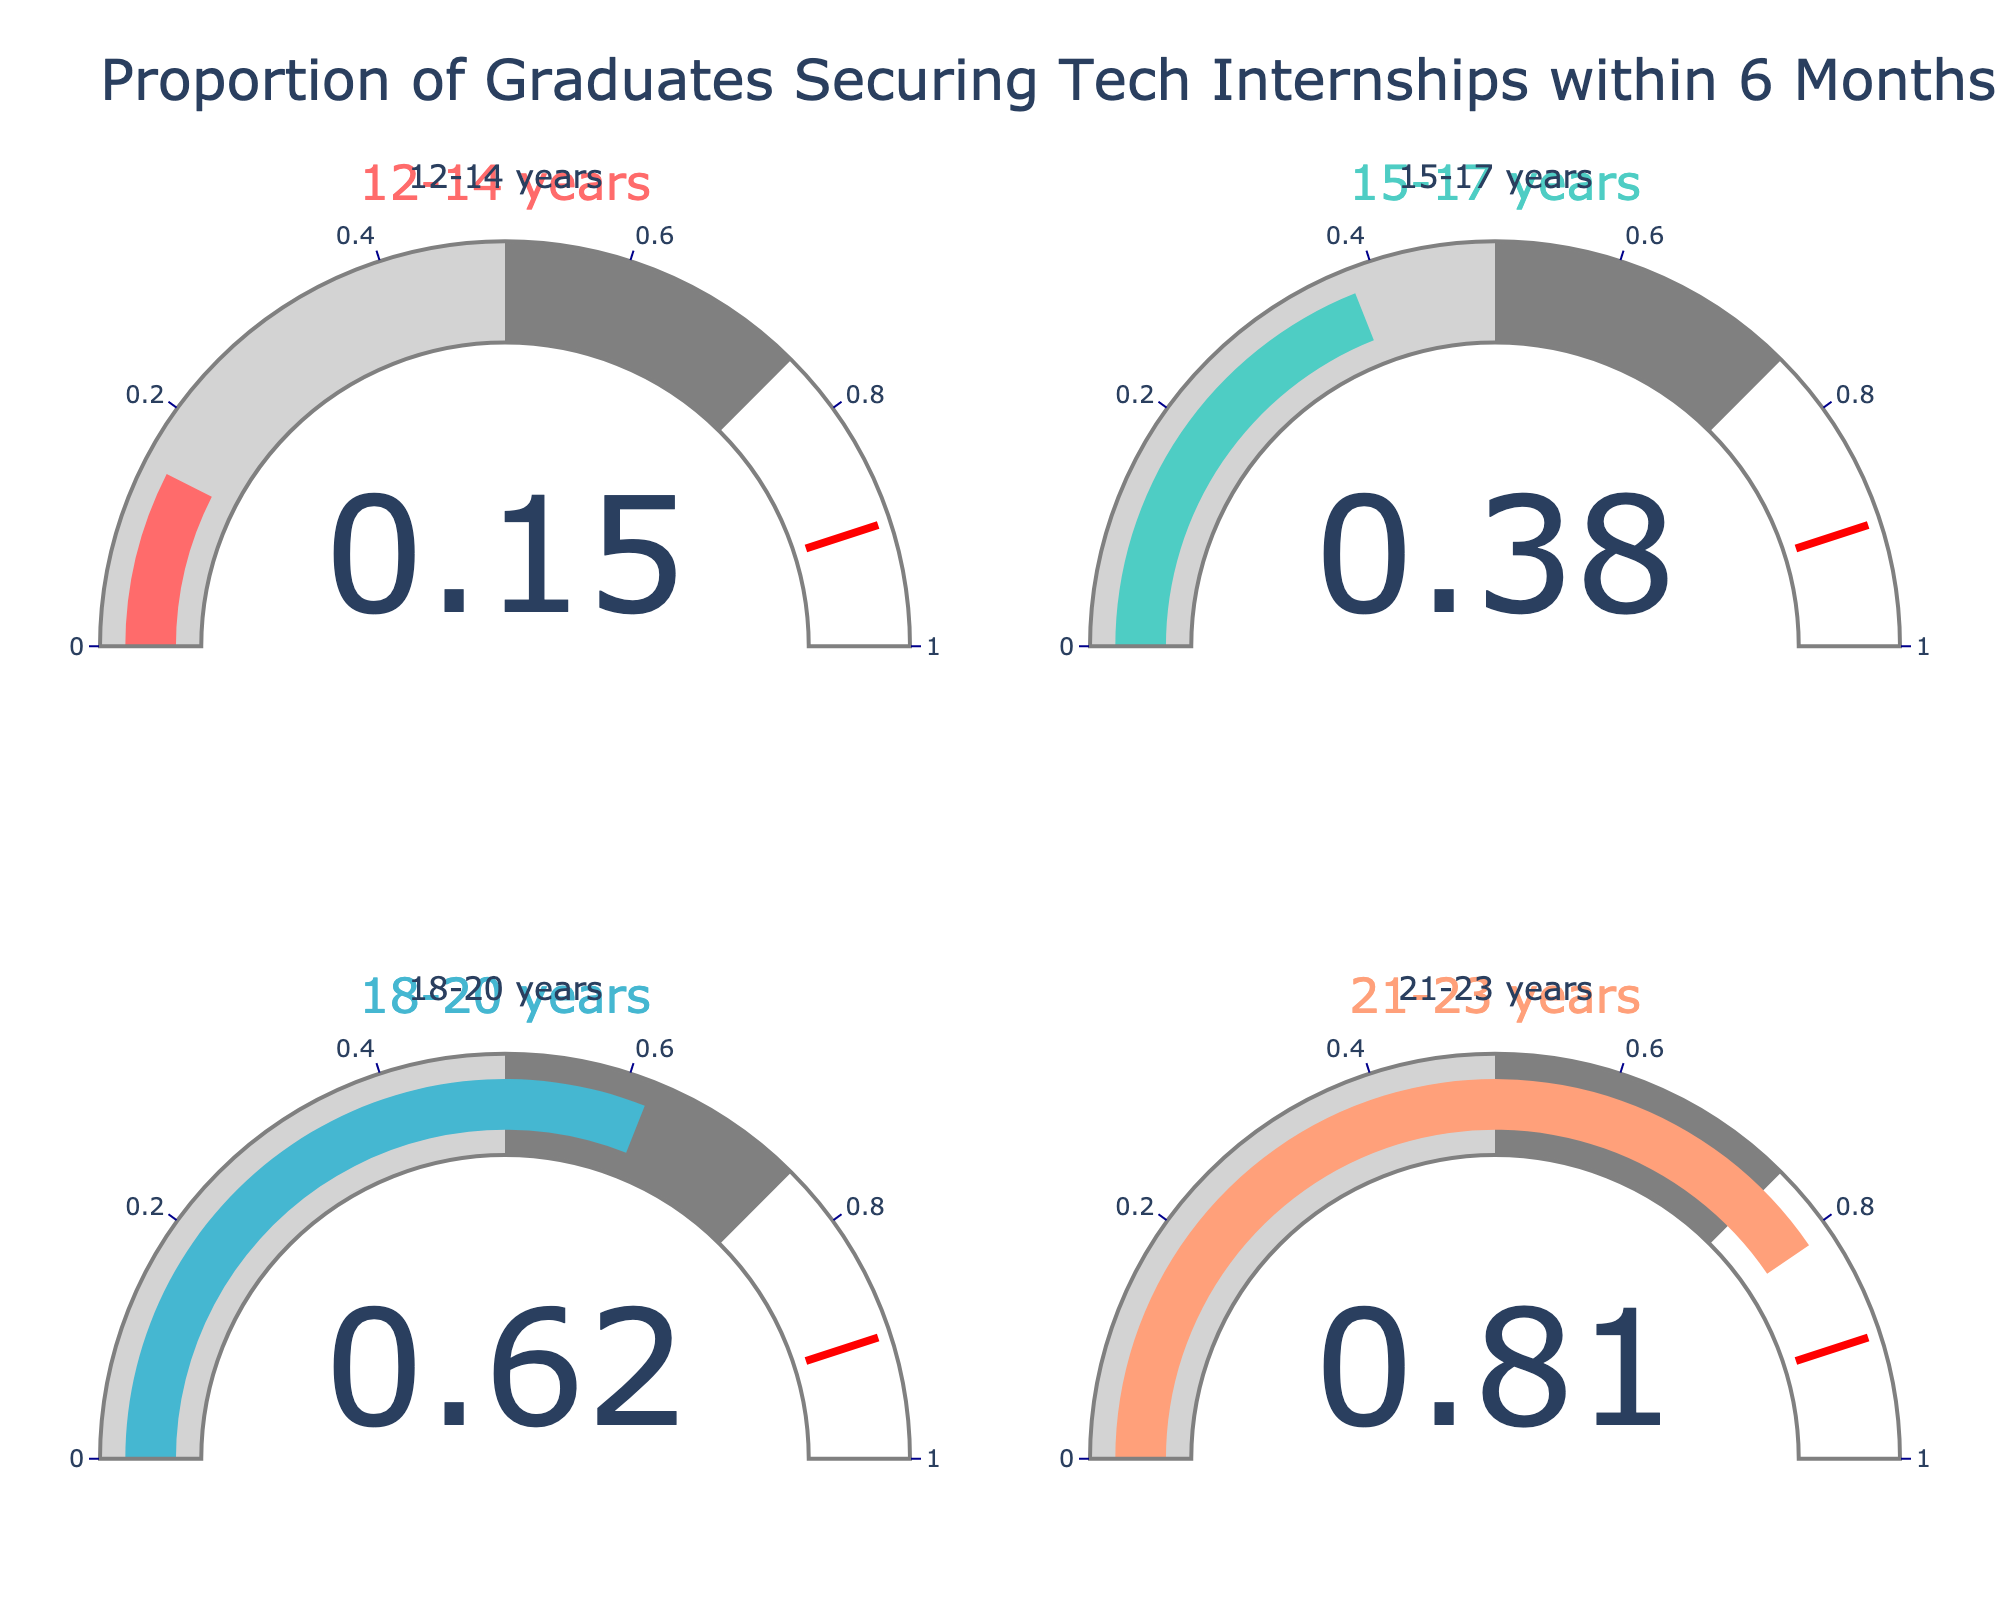What's the highest proportion of graduates securing tech internships within 6 months for different age groups? The highest proportion can be found by looking at each gauge and identifying the highest value. The gauges show 0.15 for 12-14 years, 0.38 for 15-17 years, 0.62 for 18-20 years, and 0.81 for 21-23 years. The highest value is 0.81, corresponding to the age group 21-23 years.
Answer: 0.81 Which age group has the lowest proportion of graduates securing tech internships within 6 months? The lowest proportion can be determined by looking at the gauges. The values are 0.15 (12-14 years), 0.38 (15-17 years), 0.62 (18-20 years), and 0.81 (21-23 years). The lowest value is 0.15, which corresponds to the age group 12-14 years.
Answer: 12-14 years What's the difference in proportions of graduates securing tech internships between the age groups 15-17 and 18-20? To find the difference, subtract the proportion for the age group 15-17 years (0.38) from the proportion for the age group 18-20 years (0.62). The calculation is 0.62 - 0.38 = 0.24.
Answer: 0.24 Which age group has a proportion of graduates securing tech internships closest to 0.50? To determine which value is closest to 0.50, compare the proportions. The values are 0.15, 0.38, 0.62, and 0.81. The closest value is 0.62, which belongs to the age group 18-20 years.
Answer: 18-20 years What's the average of the proportions for all age groups shown in the gauge charts? To find the average proportion, add all the proportions together and divide by the number of age groups. The proportions are 0.15, 0.38, 0.62, and 0.81. Sum these values to get 1.96, and then divide by 4 (the number of age groups) to get the average: 1.96 / 4 = 0.49.
Answer: 0.49 What is the combined proportion of graduates who secure tech internships in the age groups 12-14 and 15-17 years? To find the combined proportion, add the proportions for the age groups 12-14 years (0.15) and 15-17 years (0.38). The calculation is 0.15 + 0.38 = 0.53.
Answer: 0.53 Is the proportion of graduates securing tech internships for the age group 21-23 twice as high as that for the age group 12-14? Compare the proportion for 21-23 years (0.81) with twice the proportion for 12-14 years (0.15 * 2 = 0.30). Since 0.81 is greater than 0.30, it is more than twice as high.
Answer: Yes Which gauge has the proportion closest to the halfway threshold of 0.5? To find the closest proportion to 0.5, look at the values: 0.15, 0.38, 0.62, and 0.81. The closest value is 0.62.
Answer: 0.62 